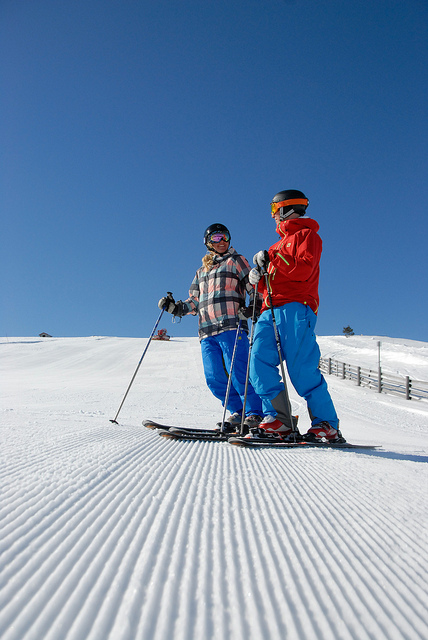Can you estimate what time of day it is based on the shadows in the image? It's challenging to give an exact time without specific details, but given the length and direction of the shadows cast by the skiers, it might be late morning or early afternoon.  Are there any indications of the location of this ski resort? The specific location of the ski resort isn't revealed in the image, but the well-groomed trails and the presence of safety fences indicate it's a managed ski resort. 